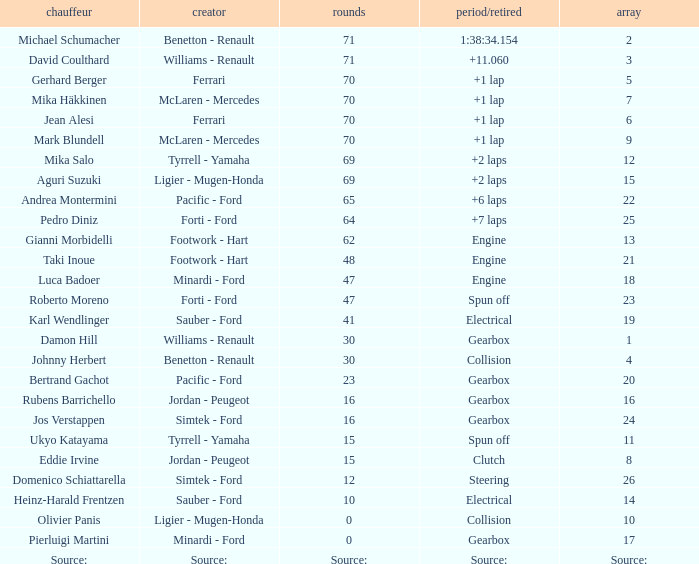David Coulthard was the driver in which grid? 3.0. 